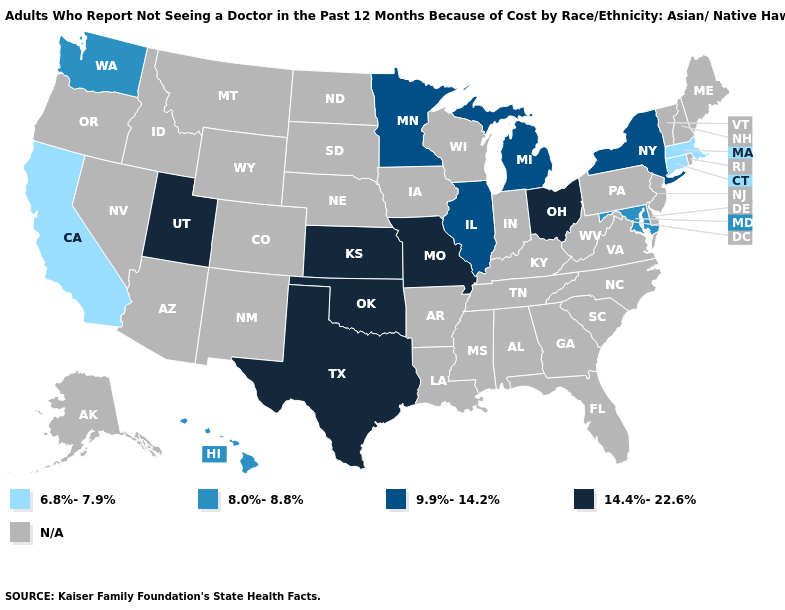Is the legend a continuous bar?
Keep it brief. No. Does Kansas have the highest value in the USA?
Give a very brief answer. Yes. Is the legend a continuous bar?
Short answer required. No. Does Texas have the lowest value in the South?
Answer briefly. No. What is the lowest value in the MidWest?
Answer briefly. 9.9%-14.2%. What is the lowest value in states that border New York?
Short answer required. 6.8%-7.9%. Does California have the highest value in the USA?
Concise answer only. No. Name the states that have a value in the range 6.8%-7.9%?
Keep it brief. California, Connecticut, Massachusetts. Among the states that border Tennessee , which have the lowest value?
Keep it brief. Missouri. What is the value of Missouri?
Short answer required. 14.4%-22.6%. Does New York have the highest value in the USA?
Quick response, please. No. Name the states that have a value in the range N/A?
Concise answer only. Alabama, Alaska, Arizona, Arkansas, Colorado, Delaware, Florida, Georgia, Idaho, Indiana, Iowa, Kentucky, Louisiana, Maine, Mississippi, Montana, Nebraska, Nevada, New Hampshire, New Jersey, New Mexico, North Carolina, North Dakota, Oregon, Pennsylvania, Rhode Island, South Carolina, South Dakota, Tennessee, Vermont, Virginia, West Virginia, Wisconsin, Wyoming. Does the first symbol in the legend represent the smallest category?
Give a very brief answer. Yes. 